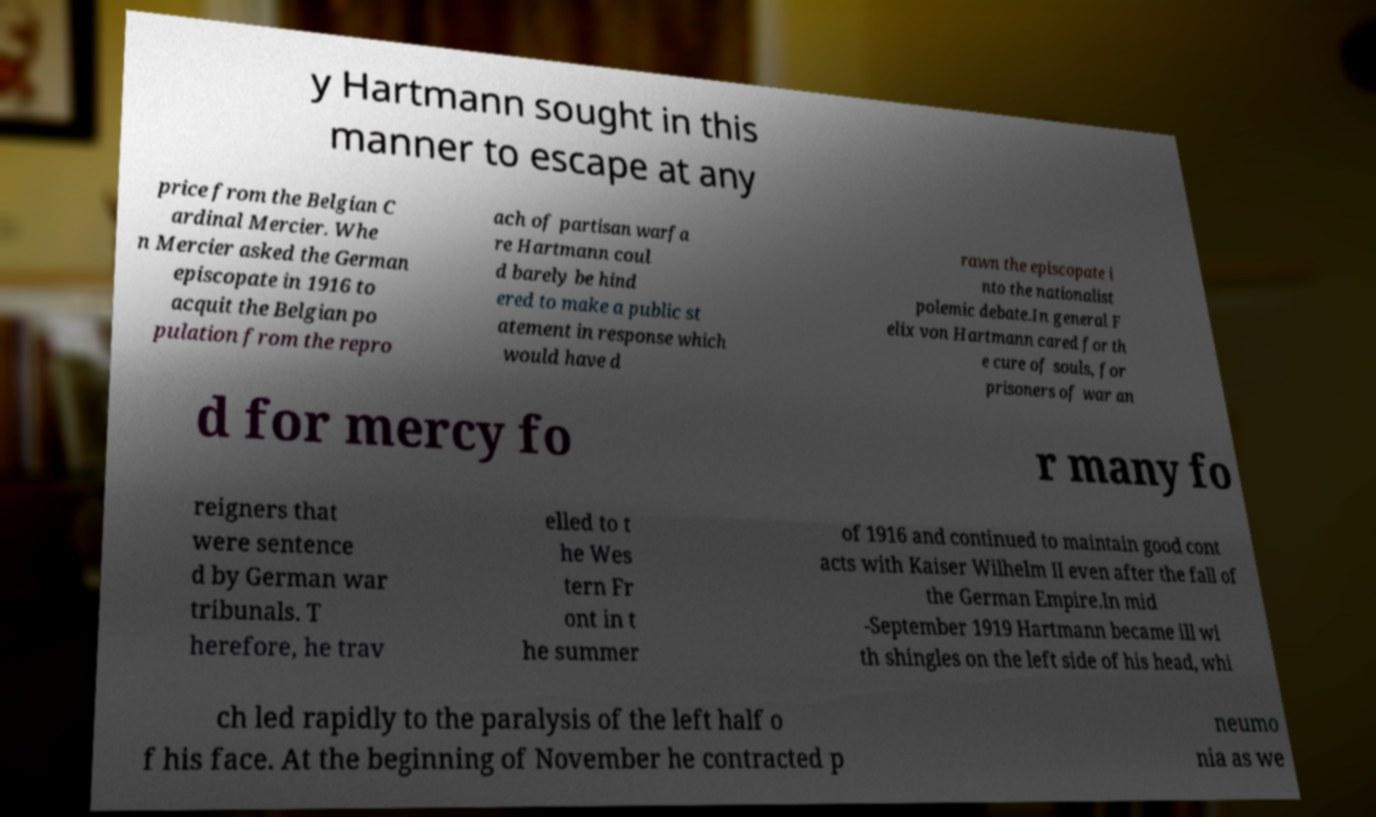Can you read and provide the text displayed in the image?This photo seems to have some interesting text. Can you extract and type it out for me? y Hartmann sought in this manner to escape at any price from the Belgian C ardinal Mercier. Whe n Mercier asked the German episcopate in 1916 to acquit the Belgian po pulation from the repro ach of partisan warfa re Hartmann coul d barely be hind ered to make a public st atement in response which would have d rawn the episcopate i nto the nationalist polemic debate.In general F elix von Hartmann cared for th e cure of souls, for prisoners of war an d for mercy fo r many fo reigners that were sentence d by German war tribunals. T herefore, he trav elled to t he Wes tern Fr ont in t he summer of 1916 and continued to maintain good cont acts with Kaiser Wilhelm II even after the fall of the German Empire.In mid -September 1919 Hartmann became ill wi th shingles on the left side of his head, whi ch led rapidly to the paralysis of the left half o f his face. At the beginning of November he contracted p neumo nia as we 